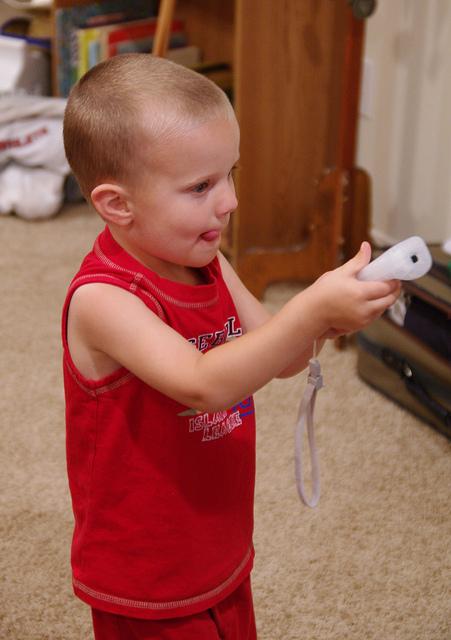Does this room have hardwood floors?
Write a very short answer. No. Does this child have long hair?
Answer briefly. No. Is this child playing with a Wii?
Give a very brief answer. Yes. What color is the child's shirt?
Keep it brief. Red. 